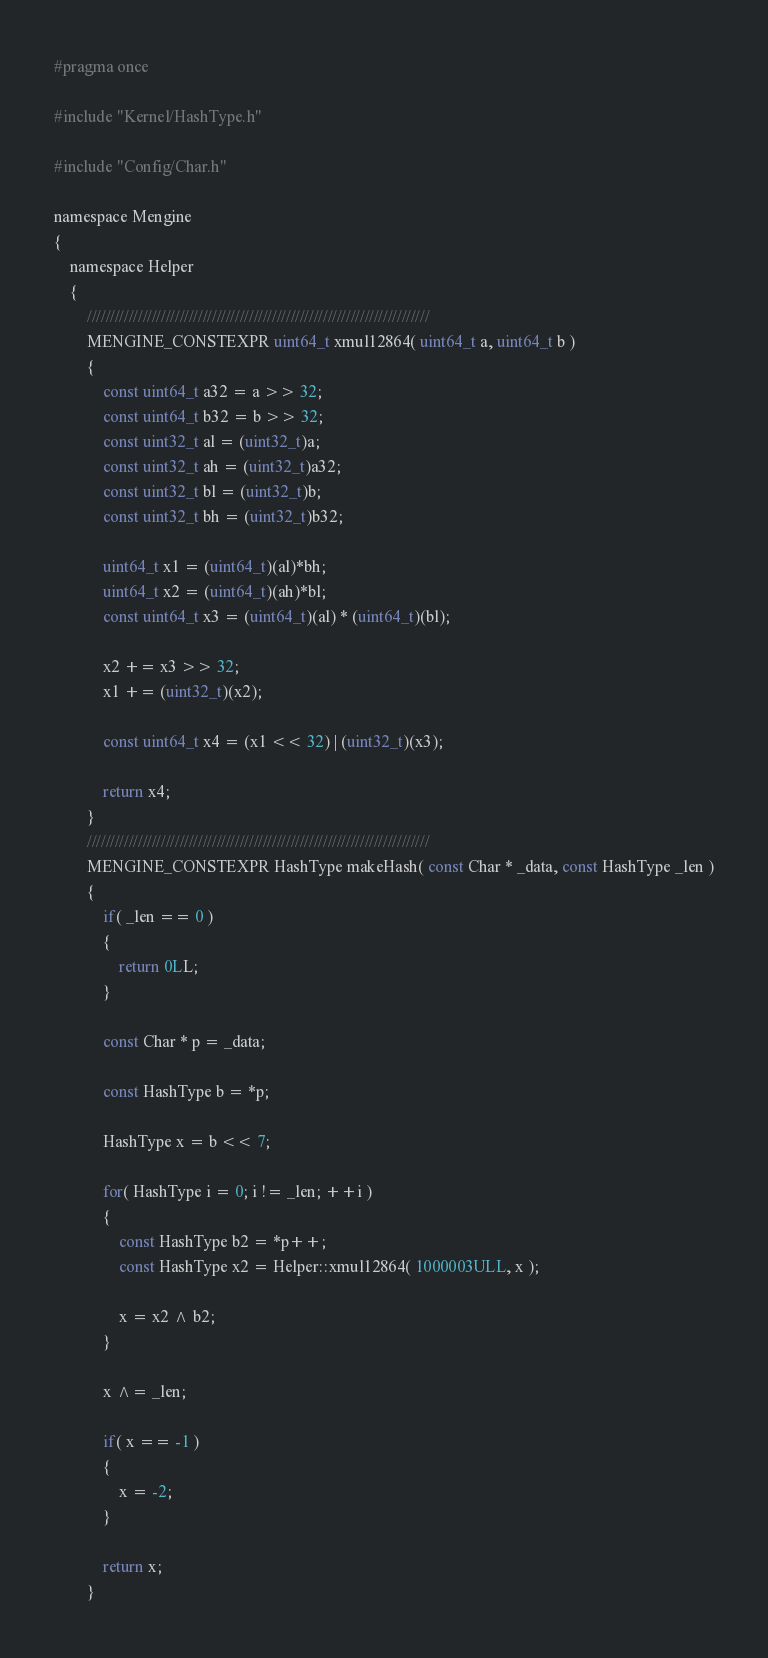Convert code to text. <code><loc_0><loc_0><loc_500><loc_500><_C_>#pragma once

#include "Kernel/HashType.h"

#include "Config/Char.h"

namespace Mengine
{
    namespace Helper
    {
        //////////////////////////////////////////////////////////////////////////
        MENGINE_CONSTEXPR uint64_t xmul12864( uint64_t a, uint64_t b )
        {
            const uint64_t a32 = a >> 32;
            const uint64_t b32 = b >> 32;
            const uint32_t al = (uint32_t)a;
            const uint32_t ah = (uint32_t)a32;
            const uint32_t bl = (uint32_t)b;
            const uint32_t bh = (uint32_t)b32;

            uint64_t x1 = (uint64_t)(al)*bh;
            uint64_t x2 = (uint64_t)(ah)*bl;
            const uint64_t x3 = (uint64_t)(al) * (uint64_t)(bl);

            x2 += x3 >> 32;
            x1 += (uint32_t)(x2);

            const uint64_t x4 = (x1 << 32) | (uint32_t)(x3);

            return x4;
        }
        //////////////////////////////////////////////////////////////////////////
        MENGINE_CONSTEXPR HashType makeHash( const Char * _data, const HashType _len )
        {
            if( _len == 0 )
            {
                return 0LL;
            }

            const Char * p = _data;

            const HashType b = *p;

            HashType x = b << 7;

            for( HashType i = 0; i != _len; ++i )
            {
                const HashType b2 = *p++;
                const HashType x2 = Helper::xmul12864( 1000003ULL, x );

                x = x2 ^ b2;
            }

            x ^= _len;

            if( x == -1 )
            {
                x = -2;
            }

            return x;
        }</code> 